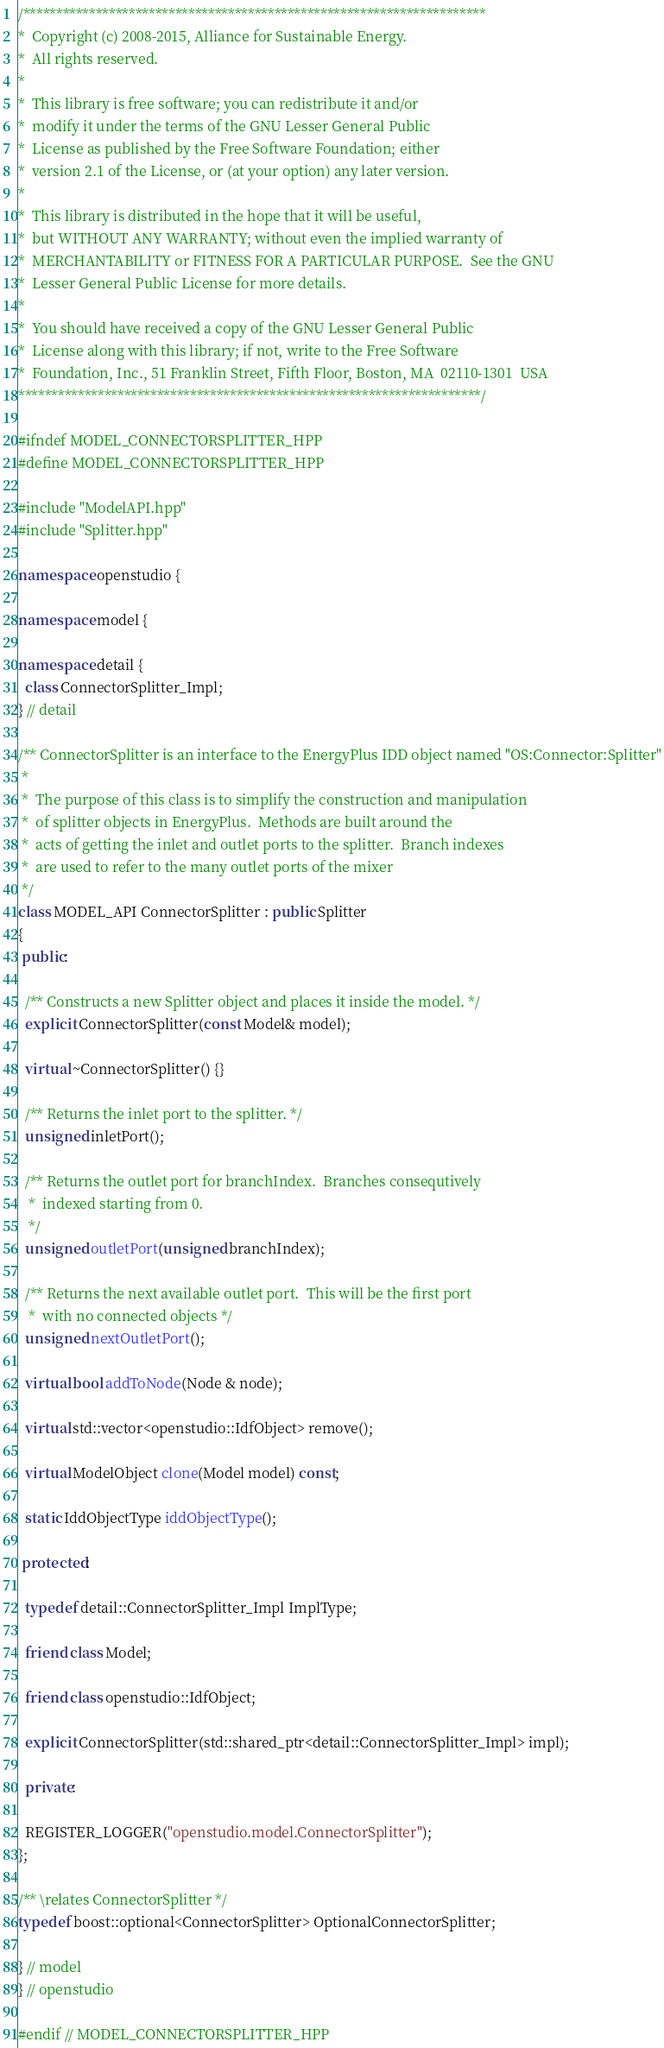<code> <loc_0><loc_0><loc_500><loc_500><_C++_>/**********************************************************************
*  Copyright (c) 2008-2015, Alliance for Sustainable Energy.
*  All rights reserved.
*
*  This library is free software; you can redistribute it and/or
*  modify it under the terms of the GNU Lesser General Public
*  License as published by the Free Software Foundation; either
*  version 2.1 of the License, or (at your option) any later version.
*
*  This library is distributed in the hope that it will be useful,
*  but WITHOUT ANY WARRANTY; without even the implied warranty of
*  MERCHANTABILITY or FITNESS FOR A PARTICULAR PURPOSE.  See the GNU
*  Lesser General Public License for more details.
*
*  You should have received a copy of the GNU Lesser General Public
*  License along with this library; if not, write to the Free Software
*  Foundation, Inc., 51 Franklin Street, Fifth Floor, Boston, MA  02110-1301  USA
**********************************************************************/

#ifndef MODEL_CONNECTORSPLITTER_HPP
#define MODEL_CONNECTORSPLITTER_HPP

#include "ModelAPI.hpp"
#include "Splitter.hpp"

namespace openstudio {

namespace model {

namespace detail {
  class ConnectorSplitter_Impl;
} // detail

/** ConnectorSplitter is an interface to the EnergyPlus IDD object named "OS:Connector:Splitter"
 *
 *  The purpose of this class is to simplify the construction and manipulation
 *  of splitter objects in EnergyPlus.  Methods are built around the
 *  acts of getting the inlet and outlet ports to the splitter.  Branch indexes
 *  are used to refer to the many outlet ports of the mixer
 */
class MODEL_API ConnectorSplitter : public Splitter
{
 public:

  /** Constructs a new Splitter object and places it inside the model. */
  explicit ConnectorSplitter(const Model& model);

  virtual ~ConnectorSplitter() {}

  /** Returns the inlet port to the splitter. */
  unsigned inletPort();

  /** Returns the outlet port for branchIndex.  Branches consequtively
   *  indexed starting from 0.
   */
  unsigned outletPort(unsigned branchIndex);

  /** Returns the next available outlet port.  This will be the first port
   *  with no connected objects */
  unsigned nextOutletPort();

  virtual bool addToNode(Node & node);

  virtual std::vector<openstudio::IdfObject> remove();

  virtual ModelObject clone(Model model) const;

  static IddObjectType iddObjectType();

 protected:

  typedef detail::ConnectorSplitter_Impl ImplType;

  friend class Model;

  friend class openstudio::IdfObject;

  explicit ConnectorSplitter(std::shared_ptr<detail::ConnectorSplitter_Impl> impl);

  private:

  REGISTER_LOGGER("openstudio.model.ConnectorSplitter");
};

/** \relates ConnectorSplitter */
typedef boost::optional<ConnectorSplitter> OptionalConnectorSplitter;

} // model
} // openstudio

#endif // MODEL_CONNECTORSPLITTER_HPP

</code> 